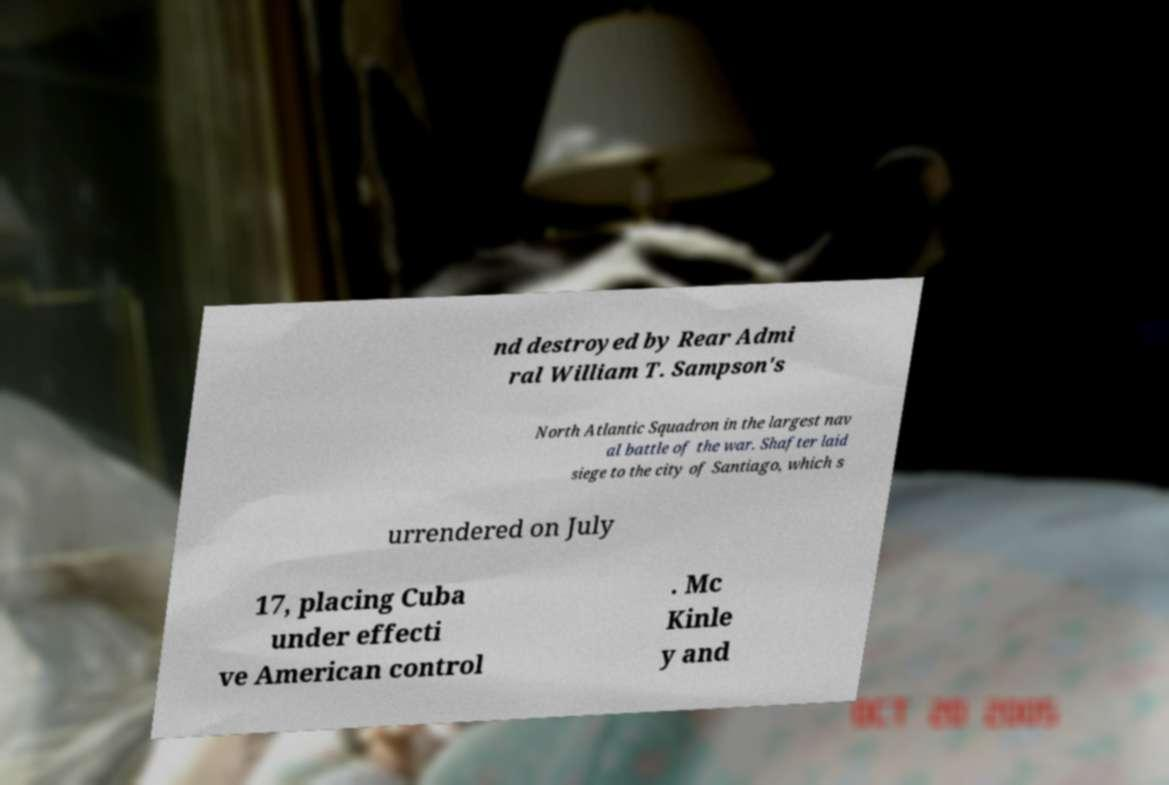Please identify and transcribe the text found in this image. nd destroyed by Rear Admi ral William T. Sampson's North Atlantic Squadron in the largest nav al battle of the war. Shafter laid siege to the city of Santiago, which s urrendered on July 17, placing Cuba under effecti ve American control . Mc Kinle y and 